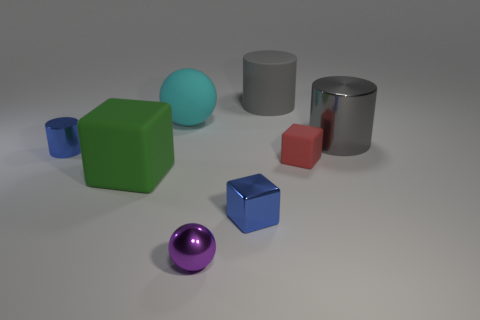Subtract all small cubes. How many cubes are left? 1 Add 2 large shiny cylinders. How many objects exist? 10 Subtract all balls. How many objects are left? 6 Add 2 balls. How many balls exist? 4 Subtract 0 yellow cylinders. How many objects are left? 8 Subtract all large blue cylinders. Subtract all big cyan rubber balls. How many objects are left? 7 Add 6 large green matte blocks. How many large green matte blocks are left? 7 